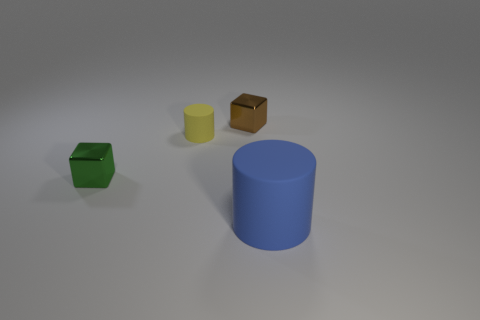Are there any other big blue objects of the same shape as the blue thing?
Make the answer very short. No. Is the number of metallic things behind the yellow object greater than the number of small metallic things?
Give a very brief answer. No. How many matte things are either large cyan spheres or blue cylinders?
Offer a very short reply. 1. There is a thing that is behind the green metallic object and on the left side of the small brown shiny cube; what size is it?
Offer a terse response. Small. Is there a small object that is on the left side of the small shiny cube to the left of the tiny matte cylinder?
Offer a very short reply. No. How many rubber things are to the right of the tiny yellow rubber thing?
Your answer should be compact. 1. What is the color of the other small metallic object that is the same shape as the green thing?
Your answer should be very brief. Brown. Are the block that is in front of the small cylinder and the small thing that is right of the tiny rubber object made of the same material?
Your answer should be compact. Yes. There is a small cylinder; is it the same color as the tiny metal block in front of the tiny brown block?
Make the answer very short. No. What shape is the object that is in front of the tiny cylinder and to the left of the big blue rubber object?
Provide a succinct answer. Cube. 